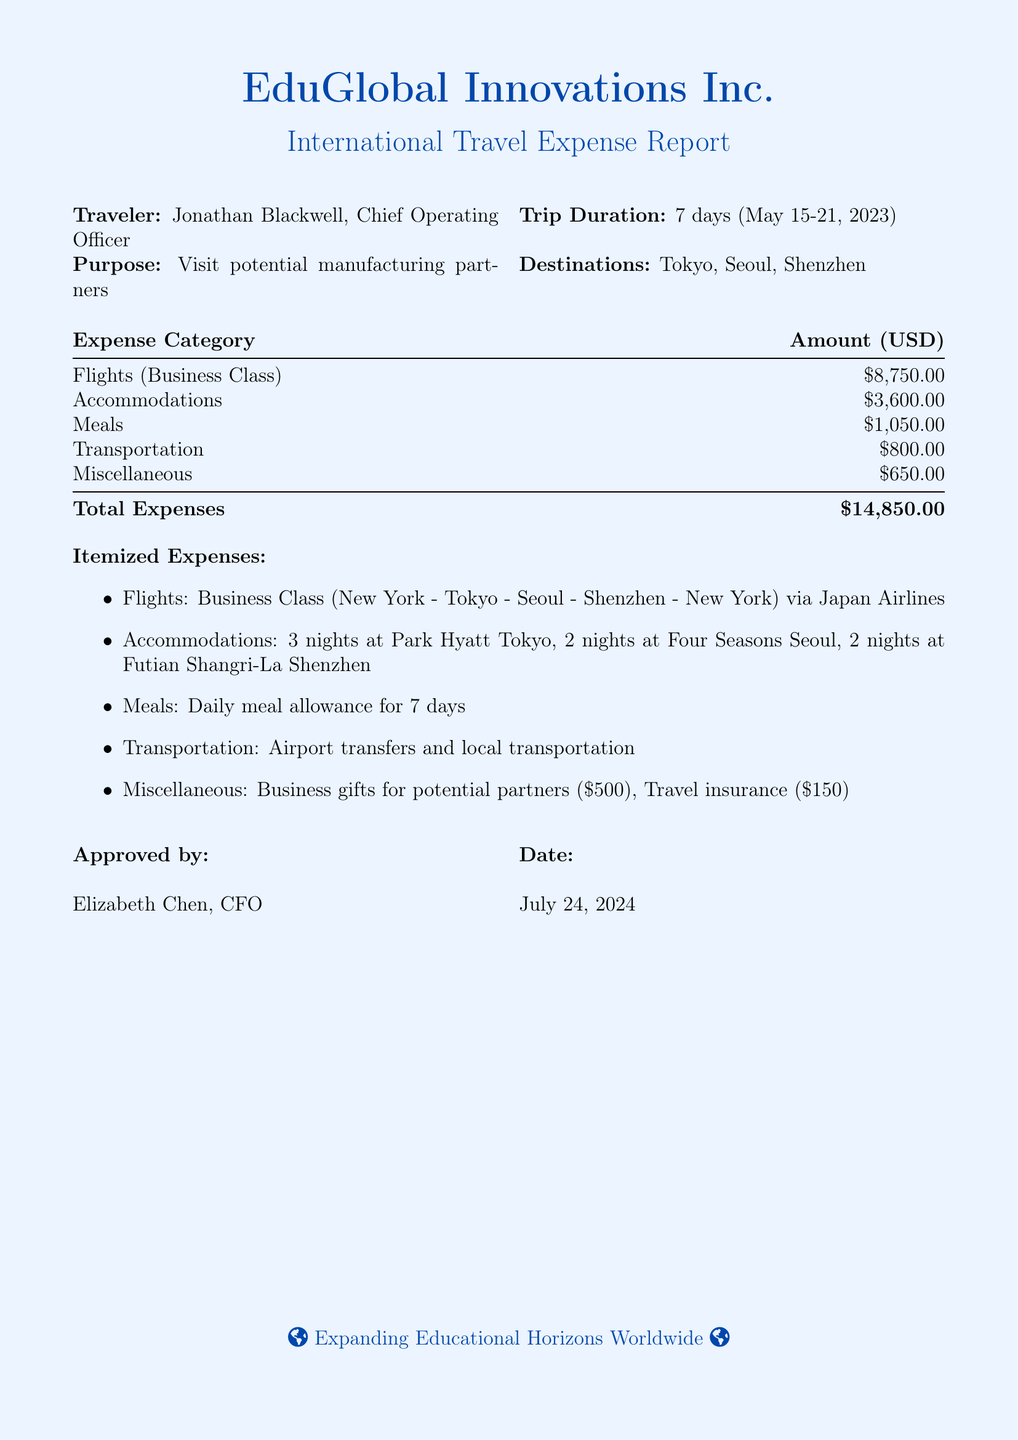What is the total expense amount? The total expense amount is provided at the end of the expense table, totaling all categories of expenses.
Answer: $14,850.00 Who is the traveler? The traveler is identified at the beginning of the document.
Answer: Jonathan Blackwell What is the duration of the trip? The trip duration is mentioned in the traveler's details section.
Answer: 7 days How many nights did the traveler stay in Tokyo? The accommodations section specifies the number of nights spent in each city.
Answer: 3 nights What is the expense amount for meals? The meals expense is listed in the itemized cost breakdown.
Answer: $1,050.00 What date was this expense report approved? The approval date is noted in the last section of the document.
Answer: Today's date What type of class were the flights booked in? The document specifies the class of tickets purchased under flights.
Answer: Business Class What were the miscellaneous expenses primarily for? The itemized expenses provide details about what the miscellaneous expenses covered.
Answer: Business gifts for potential partners How many nights did the traveler spend in Seoul? The accommodations section reveals the number of nights spent in each destination.
Answer: 2 nights 